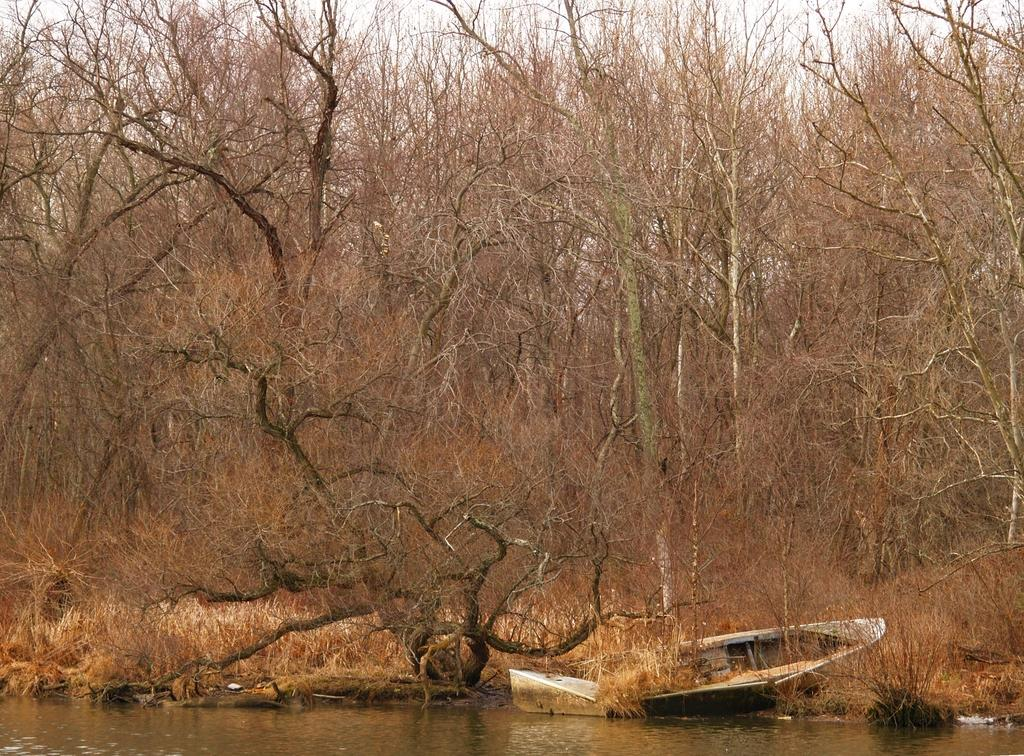What is the main subject of the image? The main subject of the image is a boat. Where is the boat located in relation to the water? The boat is near the water in the image. What can be seen in the background of the image? There are trees in the background of the image. What is visible at the top of the image? The sky is visible at the top of the image. What can be observed at the bottom of the image? There is water flow visible at the bottom of the image. What type of linen is draped over the boat in the image? There is no linen draped over the boat in the image. Can you see a veil covering the water in the image? There is no veil covering the water in the image. 